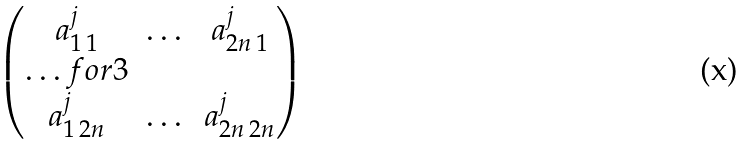Convert formula to latex. <formula><loc_0><loc_0><loc_500><loc_500>\begin{pmatrix} a ^ { j } _ { 1 \, 1 } & \dots & a ^ { j } _ { 2 n \, 1 } \\ \hdots f o r { 3 } \\ a ^ { j } _ { 1 \, 2 n } & \dots & a ^ { j } _ { 2 n \, 2 n } \end{pmatrix}</formula> 